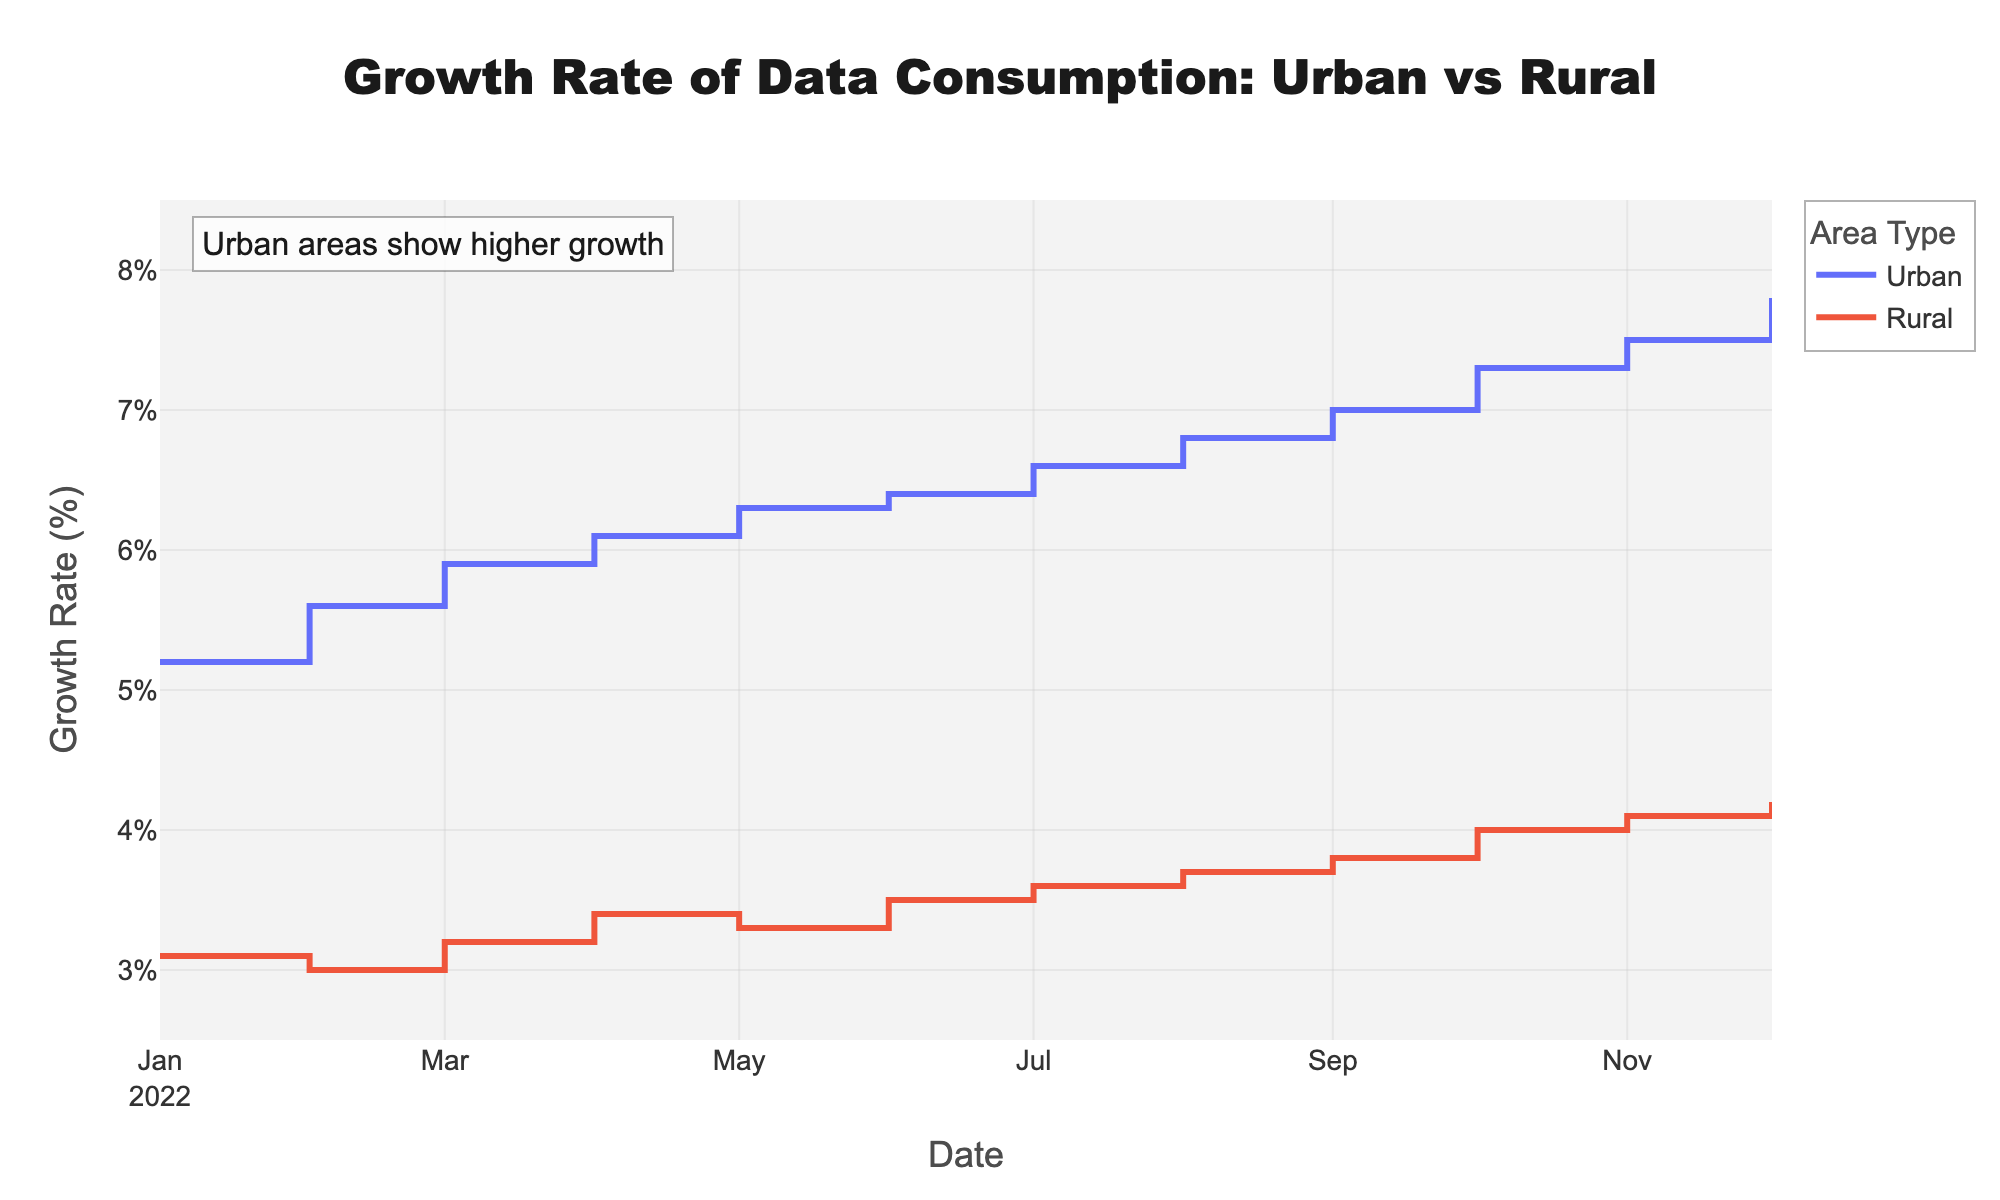What is the title of the plot? The title of the plot is displayed at the top center of the figure and reads "Growth Rate of Data Consumption: Urban vs Rural".
Answer: Growth Rate of Data Consumption: Urban vs Rural How does the growth rate in urban areas change over the year? Observing the urban line on the plot, the growth rate consistently increases each month, starting from 5.2% in January and reaching 7.8% in December.
Answer: It consistently increases What is the highest growth rate recorded for rural areas, and when did it occur? The highest growth rate for rural areas is observed in December, where it reaches 4.2%, as seen in the data points plotted for rural areas throughout the year.
Answer: 4.2% in December Which area type shows a higher growth rate overall? By comparing the heights of the two lines, the urban line is consistently plotted higher than the rural line across the entire year, indicating a higher growth rate for urban areas.
Answer: Urban areas By how much did the rural growth rate increase from January to December? The rural growth rate increased from 3.1% in January to 4.2% in December. The increase can be calculated as 4.2% - 3.1% = 1.1%.
Answer: 1.1% What trend can be observed in the urban growth rate from July to December? Observing the urban line from July onwards, the growth rate increases from 6.6% in July to 7.8% in December, indicating a positive trend.
Answer: It increases In which month do both urban and rural areas show their closest growth rates? By comparing the gaps between the lines for each month, February shows the smallest gap where urban areas have a 5.6% growth rate and rural areas have a 3.0% growth rate, a difference of 2.6%.
Answer: February What is the difference in growth rate between urban and rural areas in October? The urban growth rate in October is 7.3%, and the rural growth rate is 4.0%. The difference can be calculated as 7.3% - 4.0% = 3.3%.
Answer: 3.3% When do the rural growth rates exhibit a noticeable rise, and by how much do they increase from that point in the next two months? The noticeable rise for rural growth rates starts in September at 3.8%. It then increases to 4.0% in October and 4.1% in November, showing month-over-month increases of 0.2% and 0.1%, respectively.
Answer: September; increases of 0.2% and 0.1% Why might the annotation on the plot emphasize that "Urban areas show higher growth"? The annotation likely emphasizes this point because the urban growth rate consistently surpasses the rural growth rate every month, highlighting a significant and continuous gap in data consumption growth between urban and rural areas.
Answer: Consistently surpasses rural growth rates 